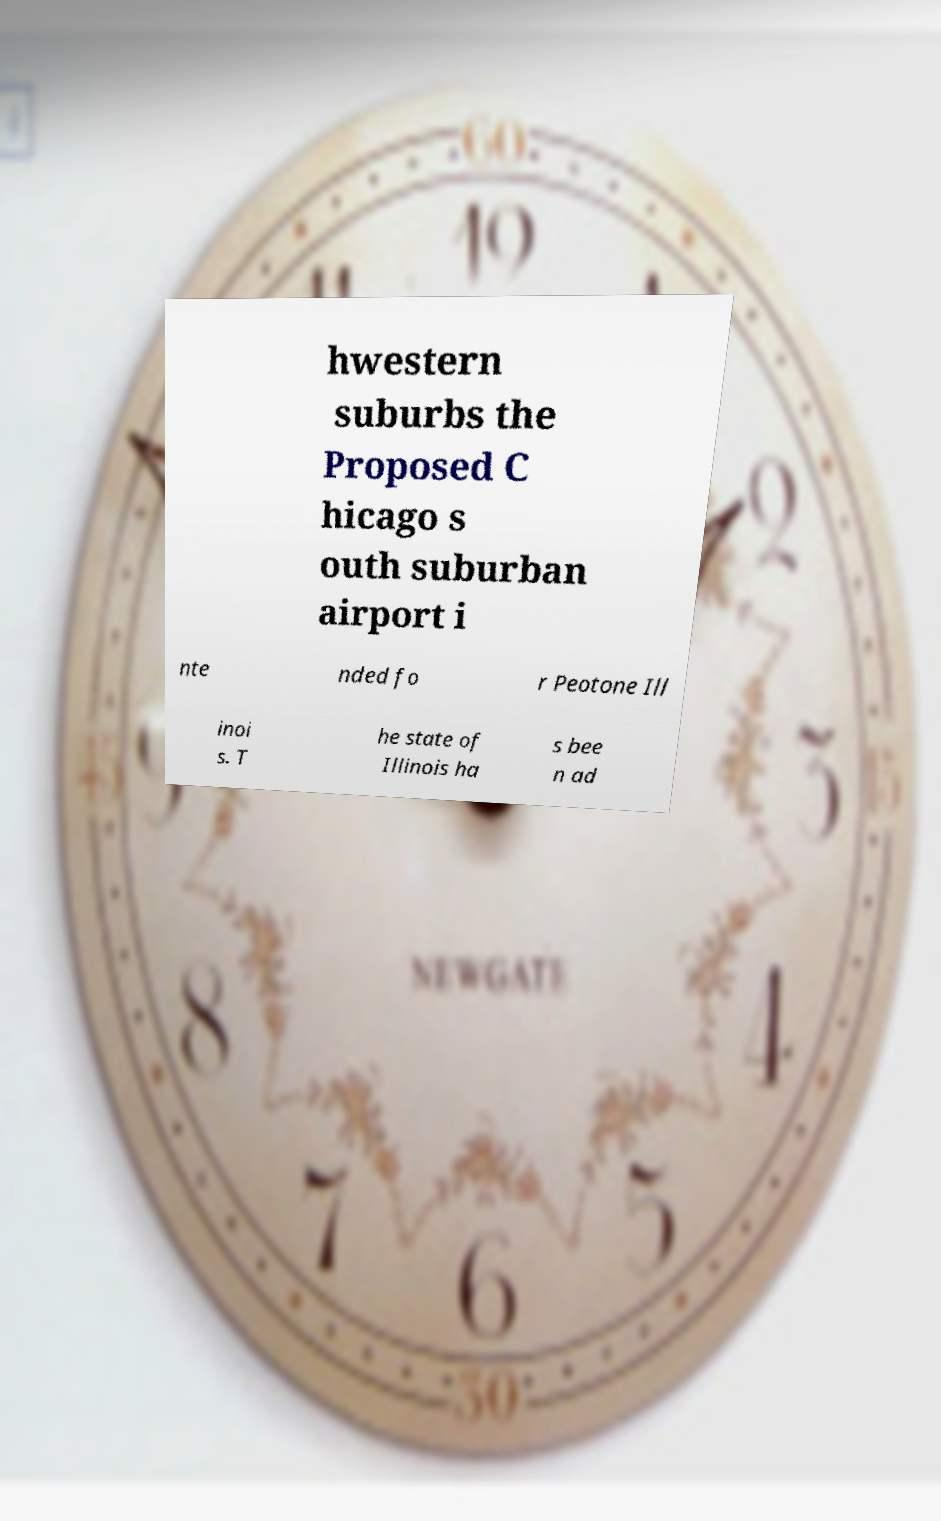Please read and relay the text visible in this image. What does it say? hwestern suburbs the Proposed C hicago s outh suburban airport i nte nded fo r Peotone Ill inoi s. T he state of Illinois ha s bee n ad 